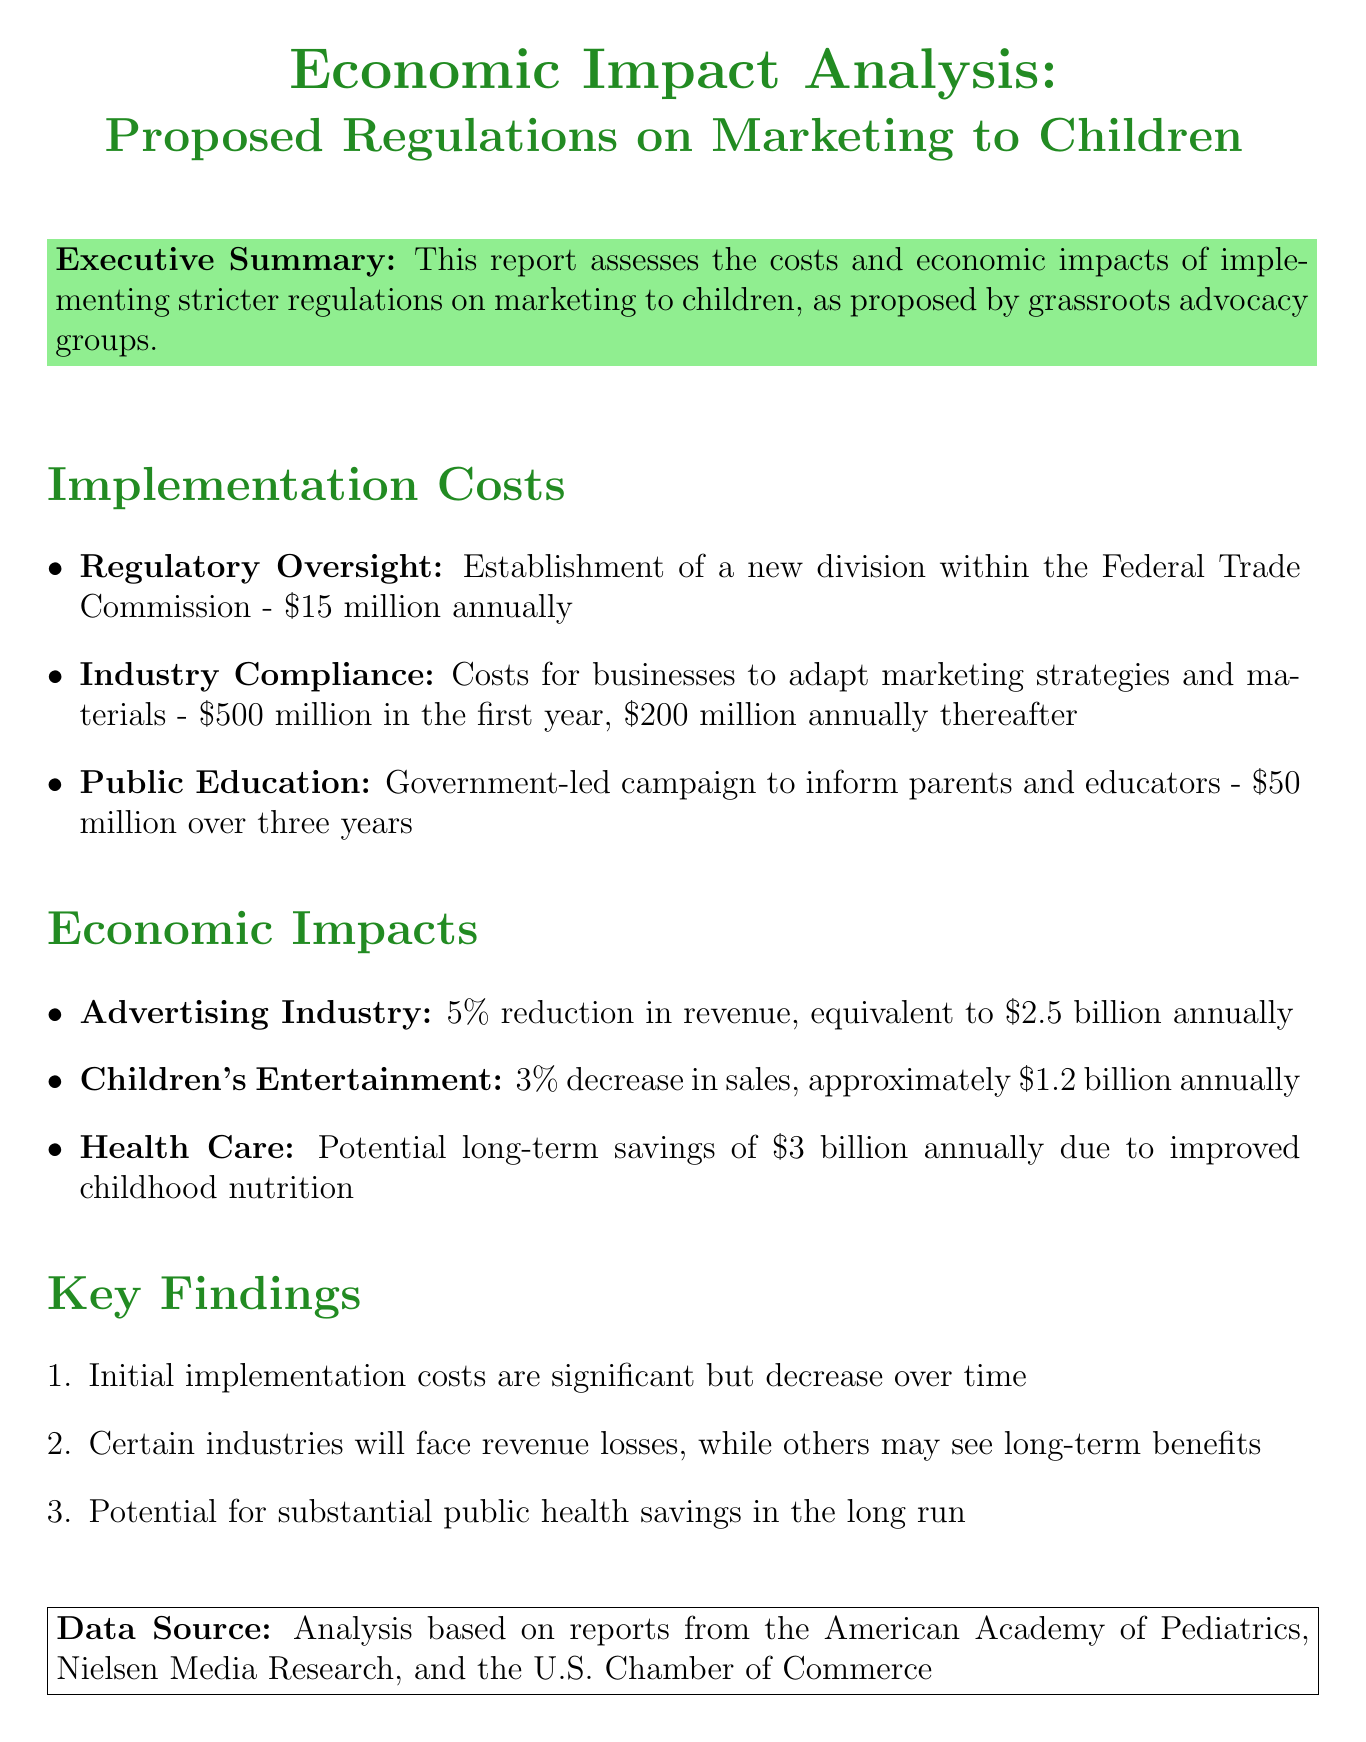What is the estimated cost for regulatory oversight? The estimated cost for regulatory oversight, as mentioned in the document, is $15 million annually.
Answer: $15 million annually What are the implementation costs for public education? The document states the implementation cost for public education is $50 million over three years.
Answer: $50 million over three years What percentage reduction in revenue is projected for the advertising industry? The document indicates a projected 5% reduction in revenue for the advertising industry.
Answer: 5% What is the projected long-term savings in health care? According to the report, the projected long-term savings in health care due to improved childhood nutrition is $3 billion annually.
Answer: $3 billion annually How much do businesses need to spend on industry compliance in the first year? The document specifies that businesses will need to spend $500 million in the first year for industry compliance.
Answer: $500 million What is a key finding regarding initial implementation costs? One key finding noted in the report is that initial implementation costs are significant but decrease over time.
Answer: Decrease over time What is the expected decrease in sales for the children's entertainment sector? The report projects a 3% decrease in sales for the children's entertainment sector.
Answer: 3% What organizations provided data for this analysis? The analysis is based on reports from the American Academy of Pediatrics, Nielsen Media Research, and the U.S. Chamber of Commerce.
Answer: American Academy of Pediatrics, Nielsen Media Research, U.S. Chamber of Commerce 